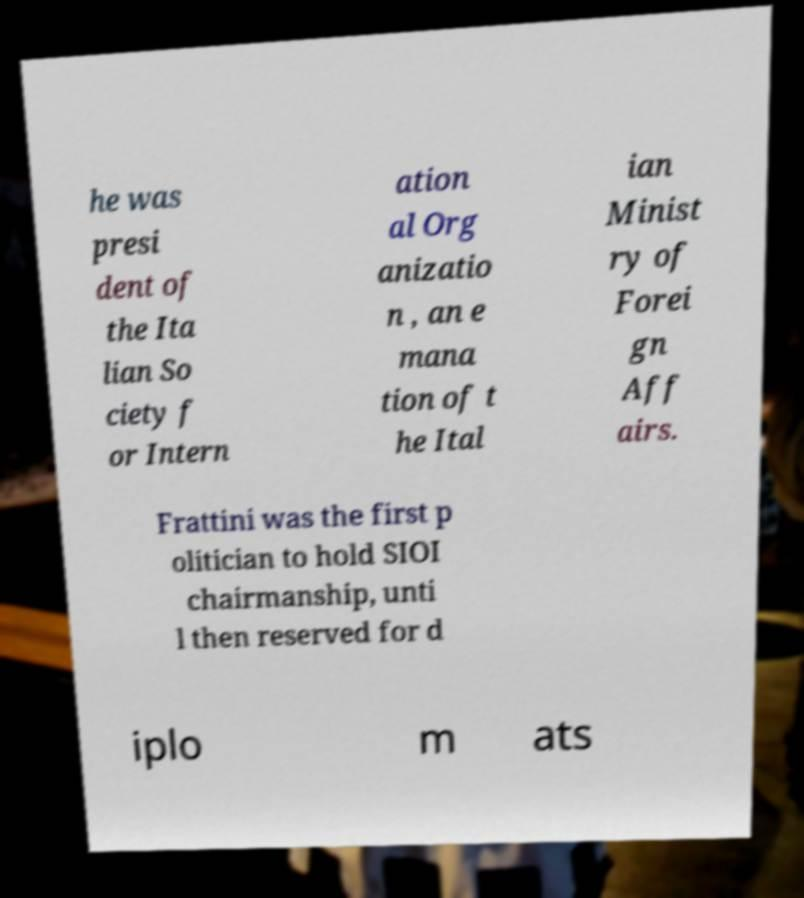I need the written content from this picture converted into text. Can you do that? he was presi dent of the Ita lian So ciety f or Intern ation al Org anizatio n , an e mana tion of t he Ital ian Minist ry of Forei gn Aff airs. Frattini was the first p olitician to hold SIOI chairmanship, unti l then reserved for d iplo m ats 